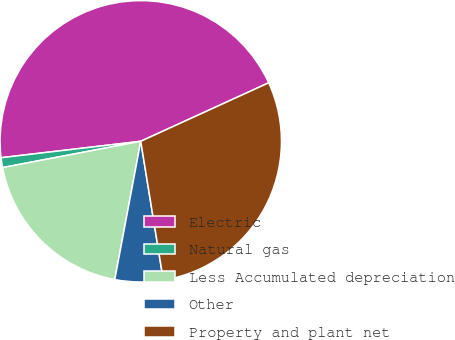Convert chart. <chart><loc_0><loc_0><loc_500><loc_500><pie_chart><fcel>Electric<fcel>Natural gas<fcel>Less Accumulated depreciation<fcel>Other<fcel>Property and plant net<nl><fcel>45.04%<fcel>1.13%<fcel>19.05%<fcel>5.52%<fcel>29.26%<nl></chart> 